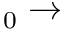<formula> <loc_0><loc_0><loc_500><loc_500>_ { 0 } \rightarrow</formula> 